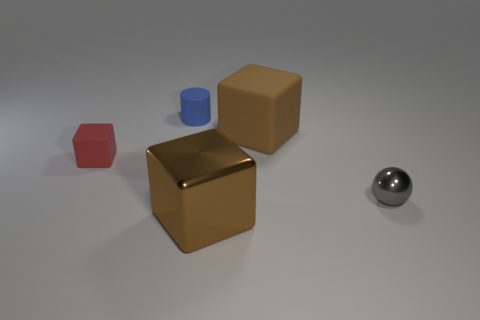Subtract all cubes. How many objects are left? 2 Subtract 1 balls. How many balls are left? 0 Subtract all red cubes. Subtract all cyan balls. How many cubes are left? 2 Subtract all blue balls. How many red cubes are left? 1 Subtract all brown rubber things. Subtract all gray things. How many objects are left? 3 Add 2 balls. How many balls are left? 3 Add 2 gray shiny objects. How many gray shiny objects exist? 3 Add 5 large brown objects. How many objects exist? 10 Subtract all brown cubes. How many cubes are left? 1 Subtract all rubber cubes. How many cubes are left? 1 